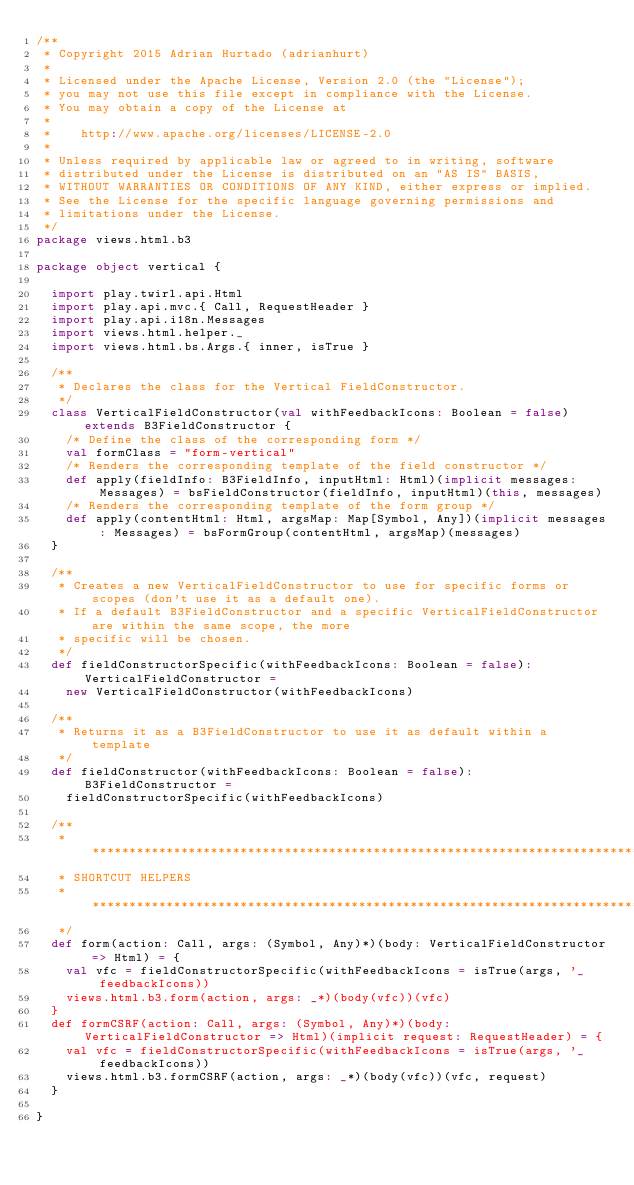Convert code to text. <code><loc_0><loc_0><loc_500><loc_500><_Scala_>/**
 * Copyright 2015 Adrian Hurtado (adrianhurt)
 *
 * Licensed under the Apache License, Version 2.0 (the "License");
 * you may not use this file except in compliance with the License.
 * You may obtain a copy of the License at
 *
 *    http://www.apache.org/licenses/LICENSE-2.0
 *
 * Unless required by applicable law or agreed to in writing, software
 * distributed under the License is distributed on an "AS IS" BASIS,
 * WITHOUT WARRANTIES OR CONDITIONS OF ANY KIND, either express or implied.
 * See the License for the specific language governing permissions and
 * limitations under the License.
 */
package views.html.b3

package object vertical {

  import play.twirl.api.Html
  import play.api.mvc.{ Call, RequestHeader }
  import play.api.i18n.Messages
  import views.html.helper._
  import views.html.bs.Args.{ inner, isTrue }

  /**
   * Declares the class for the Vertical FieldConstructor.
   */
  class VerticalFieldConstructor(val withFeedbackIcons: Boolean = false) extends B3FieldConstructor {
    /* Define the class of the corresponding form */
    val formClass = "form-vertical"
    /* Renders the corresponding template of the field constructor */
    def apply(fieldInfo: B3FieldInfo, inputHtml: Html)(implicit messages: Messages) = bsFieldConstructor(fieldInfo, inputHtml)(this, messages)
    /* Renders the corresponding template of the form group */
    def apply(contentHtml: Html, argsMap: Map[Symbol, Any])(implicit messages: Messages) = bsFormGroup(contentHtml, argsMap)(messages)
  }

  /**
   * Creates a new VerticalFieldConstructor to use for specific forms or scopes (don't use it as a default one).
   * If a default B3FieldConstructor and a specific VerticalFieldConstructor are within the same scope, the more
   * specific will be chosen.
   */
  def fieldConstructorSpecific(withFeedbackIcons: Boolean = false): VerticalFieldConstructor =
    new VerticalFieldConstructor(withFeedbackIcons)

  /**
   * Returns it as a B3FieldConstructor to use it as default within a template
   */
  def fieldConstructor(withFeedbackIcons: Boolean = false): B3FieldConstructor =
    fieldConstructorSpecific(withFeedbackIcons)

  /**
   * **********************************************************************************************************************************
   * SHORTCUT HELPERS
   * *********************************************************************************************************************************
   */
  def form(action: Call, args: (Symbol, Any)*)(body: VerticalFieldConstructor => Html) = {
    val vfc = fieldConstructorSpecific(withFeedbackIcons = isTrue(args, '_feedbackIcons))
    views.html.b3.form(action, args: _*)(body(vfc))(vfc)
  }
  def formCSRF(action: Call, args: (Symbol, Any)*)(body: VerticalFieldConstructor => Html)(implicit request: RequestHeader) = {
    val vfc = fieldConstructorSpecific(withFeedbackIcons = isTrue(args, '_feedbackIcons))
    views.html.b3.formCSRF(action, args: _*)(body(vfc))(vfc, request)
  }

}</code> 